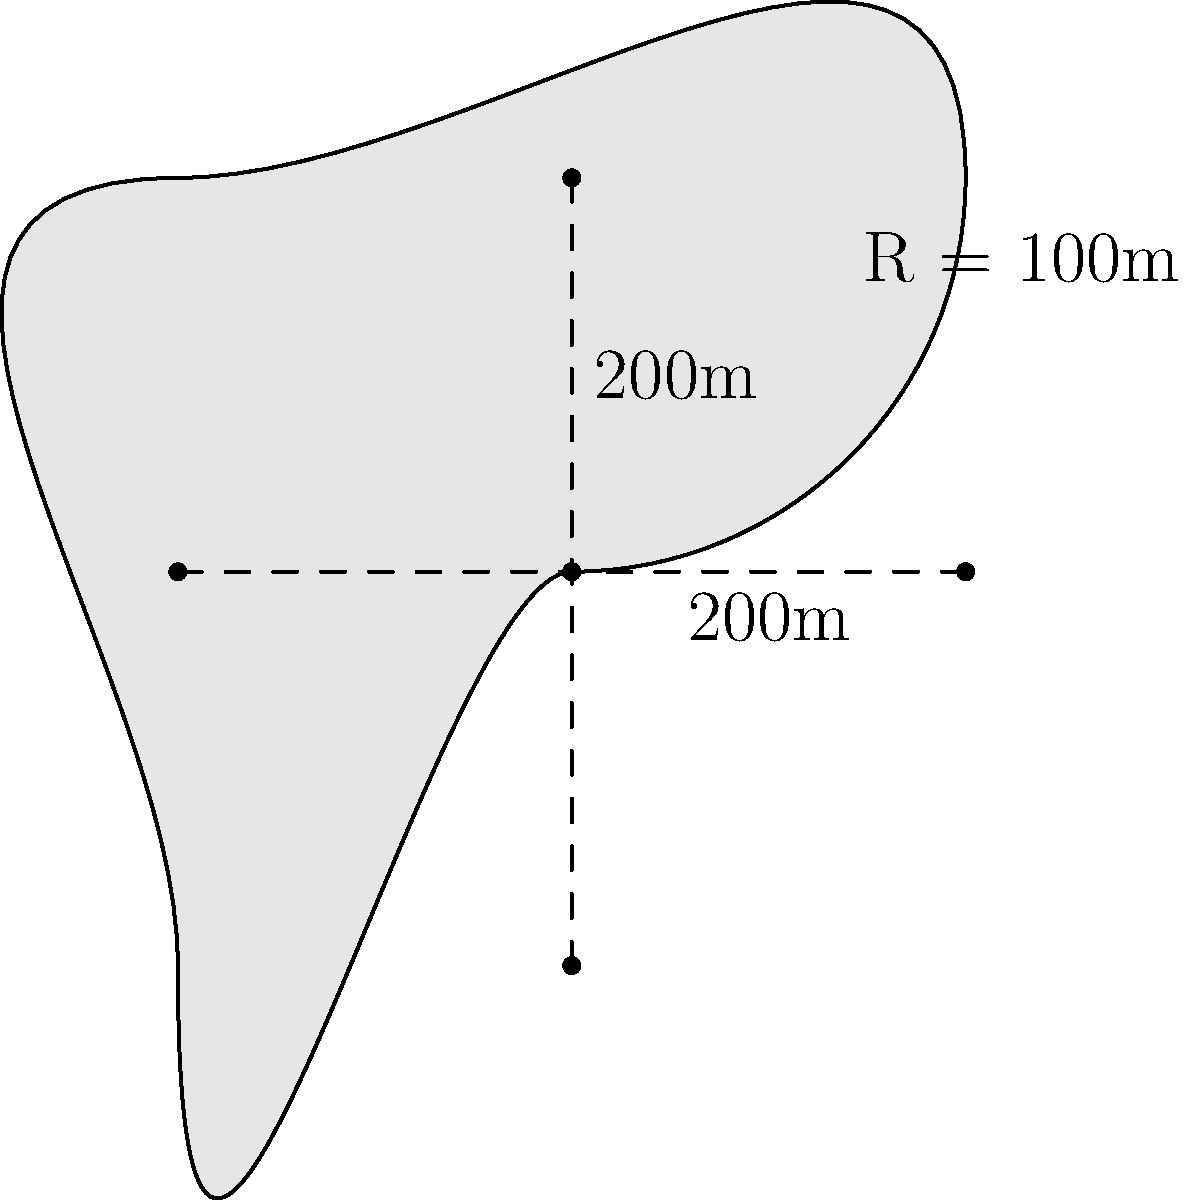At the prestigious Tokyo Racecourse, a new training track is being designed with a unique shape. The track consists of two straight sections, each 200 meters long, connected by two semicircular curves with a radius of 100 meters. As an expert commentator, you're asked to calculate the total area of this racetrack. What is the area in square meters? Let's break this down step-by-step:

1) The track consists of two rectangles (straight sections) and two semicircles.

2) Area of rectangles:
   - Each rectangle is 200m x 100m
   - Area of one rectangle: $A_r = 200m \times 100m = 20,000m^2$
   - Total area of rectangles: $2 \times 20,000m^2 = 40,000m^2$

3) Area of semicircles:
   - Radius of each semicircle is 100m
   - Area of a full circle: $A_c = \pi r^2 = \pi \times (100m)^2 = 10,000\pi m^2$
   - Area of one semicircle: $A_s = \frac{1}{2} \times 10,000\pi m^2 = 5,000\pi m^2$
   - Total area of two semicircles: $2 \times 5,000\pi m^2 = 10,000\pi m^2$

4) Total area of the racetrack:
   $A_{total} = 40,000m^2 + 10,000\pi m^2$
   $= 40,000 + 31,415.93 = 71,415.93m^2$

Therefore, the total area of the racetrack is approximately 71,415.93 square meters.
Answer: 71,415.93 m² 